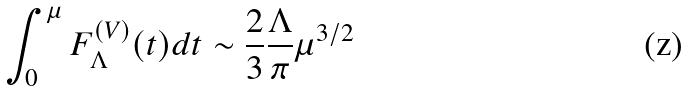<formula> <loc_0><loc_0><loc_500><loc_500>\int _ { 0 } ^ { \mu } F _ { \Lambda } ^ { ( V ) } ( t ) d t \sim \frac { 2 } { 3 } \frac { \Lambda } { \pi } \mu ^ { 3 / 2 }</formula> 